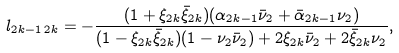<formula> <loc_0><loc_0><loc_500><loc_500>l _ { 2 k - 1 \, 2 k } = - \frac { ( 1 + \xi _ { 2 k } \bar { \xi } _ { 2 k } ) ( \alpha _ { 2 k - 1 } \bar { \nu } _ { 2 } + \bar { \alpha } _ { 2 k - 1 } \nu _ { 2 } ) } { ( 1 - \xi _ { 2 k } \bar { \xi } _ { 2 k } ) ( 1 - \nu _ { 2 } \bar { \nu } _ { 2 } ) + 2 \xi _ { 2 k } \bar { \nu } _ { 2 } + 2 \bar { \xi } _ { 2 k } \nu _ { 2 } } ,</formula> 